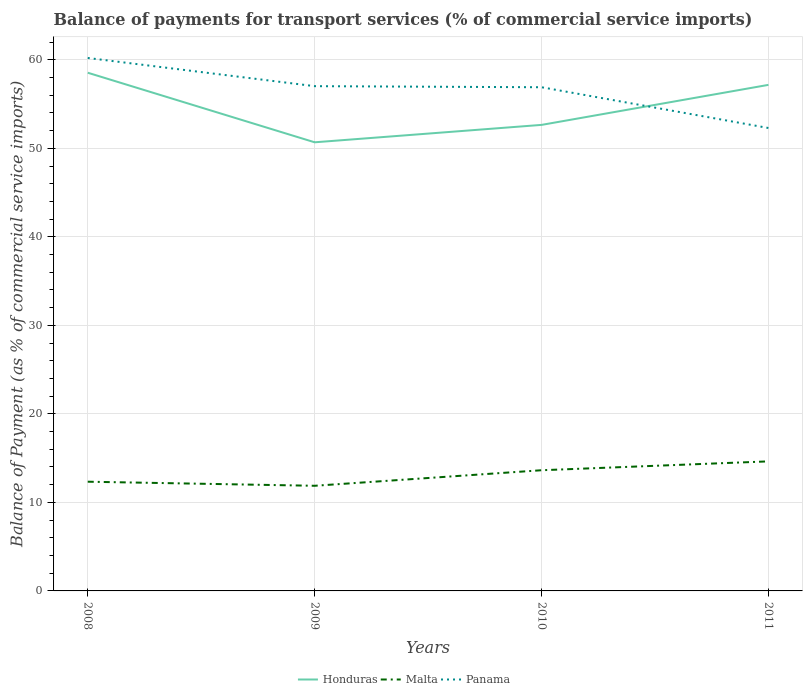How many different coloured lines are there?
Make the answer very short. 3. Across all years, what is the maximum balance of payments for transport services in Panama?
Offer a very short reply. 52.3. What is the total balance of payments for transport services in Honduras in the graph?
Offer a terse response. -4.52. What is the difference between the highest and the second highest balance of payments for transport services in Panama?
Your answer should be very brief. 7.91. What is the difference between the highest and the lowest balance of payments for transport services in Malta?
Provide a short and direct response. 2. What is the difference between two consecutive major ticks on the Y-axis?
Make the answer very short. 10. Does the graph contain grids?
Your answer should be very brief. Yes. What is the title of the graph?
Make the answer very short. Balance of payments for transport services (% of commercial service imports). Does "World" appear as one of the legend labels in the graph?
Provide a succinct answer. No. What is the label or title of the Y-axis?
Your answer should be compact. Balance of Payment (as % of commercial service imports). What is the Balance of Payment (as % of commercial service imports) in Honduras in 2008?
Make the answer very short. 58.54. What is the Balance of Payment (as % of commercial service imports) in Malta in 2008?
Keep it short and to the point. 12.34. What is the Balance of Payment (as % of commercial service imports) in Panama in 2008?
Keep it short and to the point. 60.21. What is the Balance of Payment (as % of commercial service imports) of Honduras in 2009?
Give a very brief answer. 50.68. What is the Balance of Payment (as % of commercial service imports) of Malta in 2009?
Your answer should be very brief. 11.88. What is the Balance of Payment (as % of commercial service imports) in Panama in 2009?
Offer a very short reply. 57.02. What is the Balance of Payment (as % of commercial service imports) in Honduras in 2010?
Provide a succinct answer. 52.65. What is the Balance of Payment (as % of commercial service imports) in Malta in 2010?
Offer a very short reply. 13.63. What is the Balance of Payment (as % of commercial service imports) of Panama in 2010?
Make the answer very short. 56.9. What is the Balance of Payment (as % of commercial service imports) of Honduras in 2011?
Your response must be concise. 57.17. What is the Balance of Payment (as % of commercial service imports) in Malta in 2011?
Your response must be concise. 14.64. What is the Balance of Payment (as % of commercial service imports) in Panama in 2011?
Give a very brief answer. 52.3. Across all years, what is the maximum Balance of Payment (as % of commercial service imports) in Honduras?
Provide a succinct answer. 58.54. Across all years, what is the maximum Balance of Payment (as % of commercial service imports) in Malta?
Offer a very short reply. 14.64. Across all years, what is the maximum Balance of Payment (as % of commercial service imports) in Panama?
Your answer should be very brief. 60.21. Across all years, what is the minimum Balance of Payment (as % of commercial service imports) in Honduras?
Provide a succinct answer. 50.68. Across all years, what is the minimum Balance of Payment (as % of commercial service imports) of Malta?
Your answer should be very brief. 11.88. Across all years, what is the minimum Balance of Payment (as % of commercial service imports) in Panama?
Provide a succinct answer. 52.3. What is the total Balance of Payment (as % of commercial service imports) of Honduras in the graph?
Your answer should be very brief. 219.04. What is the total Balance of Payment (as % of commercial service imports) of Malta in the graph?
Your response must be concise. 52.49. What is the total Balance of Payment (as % of commercial service imports) of Panama in the graph?
Make the answer very short. 226.43. What is the difference between the Balance of Payment (as % of commercial service imports) of Honduras in 2008 and that in 2009?
Provide a short and direct response. 7.86. What is the difference between the Balance of Payment (as % of commercial service imports) in Malta in 2008 and that in 2009?
Make the answer very short. 0.46. What is the difference between the Balance of Payment (as % of commercial service imports) of Panama in 2008 and that in 2009?
Keep it short and to the point. 3.19. What is the difference between the Balance of Payment (as % of commercial service imports) in Honduras in 2008 and that in 2010?
Your answer should be very brief. 5.89. What is the difference between the Balance of Payment (as % of commercial service imports) of Malta in 2008 and that in 2010?
Ensure brevity in your answer.  -1.3. What is the difference between the Balance of Payment (as % of commercial service imports) in Panama in 2008 and that in 2010?
Keep it short and to the point. 3.31. What is the difference between the Balance of Payment (as % of commercial service imports) in Honduras in 2008 and that in 2011?
Provide a succinct answer. 1.37. What is the difference between the Balance of Payment (as % of commercial service imports) of Malta in 2008 and that in 2011?
Ensure brevity in your answer.  -2.3. What is the difference between the Balance of Payment (as % of commercial service imports) in Panama in 2008 and that in 2011?
Keep it short and to the point. 7.91. What is the difference between the Balance of Payment (as % of commercial service imports) in Honduras in 2009 and that in 2010?
Ensure brevity in your answer.  -1.97. What is the difference between the Balance of Payment (as % of commercial service imports) in Malta in 2009 and that in 2010?
Your response must be concise. -1.76. What is the difference between the Balance of Payment (as % of commercial service imports) in Panama in 2009 and that in 2010?
Offer a terse response. 0.12. What is the difference between the Balance of Payment (as % of commercial service imports) of Honduras in 2009 and that in 2011?
Ensure brevity in your answer.  -6.49. What is the difference between the Balance of Payment (as % of commercial service imports) of Malta in 2009 and that in 2011?
Your answer should be compact. -2.76. What is the difference between the Balance of Payment (as % of commercial service imports) of Panama in 2009 and that in 2011?
Make the answer very short. 4.73. What is the difference between the Balance of Payment (as % of commercial service imports) in Honduras in 2010 and that in 2011?
Ensure brevity in your answer.  -4.52. What is the difference between the Balance of Payment (as % of commercial service imports) in Malta in 2010 and that in 2011?
Provide a succinct answer. -1. What is the difference between the Balance of Payment (as % of commercial service imports) in Panama in 2010 and that in 2011?
Keep it short and to the point. 4.61. What is the difference between the Balance of Payment (as % of commercial service imports) of Honduras in 2008 and the Balance of Payment (as % of commercial service imports) of Malta in 2009?
Keep it short and to the point. 46.66. What is the difference between the Balance of Payment (as % of commercial service imports) of Honduras in 2008 and the Balance of Payment (as % of commercial service imports) of Panama in 2009?
Offer a terse response. 1.52. What is the difference between the Balance of Payment (as % of commercial service imports) in Malta in 2008 and the Balance of Payment (as % of commercial service imports) in Panama in 2009?
Provide a short and direct response. -44.68. What is the difference between the Balance of Payment (as % of commercial service imports) of Honduras in 2008 and the Balance of Payment (as % of commercial service imports) of Malta in 2010?
Make the answer very short. 44.91. What is the difference between the Balance of Payment (as % of commercial service imports) in Honduras in 2008 and the Balance of Payment (as % of commercial service imports) in Panama in 2010?
Offer a terse response. 1.64. What is the difference between the Balance of Payment (as % of commercial service imports) of Malta in 2008 and the Balance of Payment (as % of commercial service imports) of Panama in 2010?
Ensure brevity in your answer.  -44.56. What is the difference between the Balance of Payment (as % of commercial service imports) of Honduras in 2008 and the Balance of Payment (as % of commercial service imports) of Malta in 2011?
Your response must be concise. 43.91. What is the difference between the Balance of Payment (as % of commercial service imports) in Honduras in 2008 and the Balance of Payment (as % of commercial service imports) in Panama in 2011?
Keep it short and to the point. 6.25. What is the difference between the Balance of Payment (as % of commercial service imports) of Malta in 2008 and the Balance of Payment (as % of commercial service imports) of Panama in 2011?
Offer a terse response. -39.96. What is the difference between the Balance of Payment (as % of commercial service imports) in Honduras in 2009 and the Balance of Payment (as % of commercial service imports) in Malta in 2010?
Your answer should be very brief. 37.05. What is the difference between the Balance of Payment (as % of commercial service imports) in Honduras in 2009 and the Balance of Payment (as % of commercial service imports) in Panama in 2010?
Make the answer very short. -6.22. What is the difference between the Balance of Payment (as % of commercial service imports) in Malta in 2009 and the Balance of Payment (as % of commercial service imports) in Panama in 2010?
Offer a terse response. -45.02. What is the difference between the Balance of Payment (as % of commercial service imports) in Honduras in 2009 and the Balance of Payment (as % of commercial service imports) in Malta in 2011?
Ensure brevity in your answer.  36.05. What is the difference between the Balance of Payment (as % of commercial service imports) in Honduras in 2009 and the Balance of Payment (as % of commercial service imports) in Panama in 2011?
Make the answer very short. -1.61. What is the difference between the Balance of Payment (as % of commercial service imports) of Malta in 2009 and the Balance of Payment (as % of commercial service imports) of Panama in 2011?
Your response must be concise. -40.42. What is the difference between the Balance of Payment (as % of commercial service imports) in Honduras in 2010 and the Balance of Payment (as % of commercial service imports) in Malta in 2011?
Provide a succinct answer. 38.01. What is the difference between the Balance of Payment (as % of commercial service imports) of Honduras in 2010 and the Balance of Payment (as % of commercial service imports) of Panama in 2011?
Ensure brevity in your answer.  0.35. What is the difference between the Balance of Payment (as % of commercial service imports) in Malta in 2010 and the Balance of Payment (as % of commercial service imports) in Panama in 2011?
Your response must be concise. -38.66. What is the average Balance of Payment (as % of commercial service imports) in Honduras per year?
Offer a very short reply. 54.76. What is the average Balance of Payment (as % of commercial service imports) in Malta per year?
Give a very brief answer. 13.12. What is the average Balance of Payment (as % of commercial service imports) in Panama per year?
Keep it short and to the point. 56.61. In the year 2008, what is the difference between the Balance of Payment (as % of commercial service imports) of Honduras and Balance of Payment (as % of commercial service imports) of Malta?
Provide a succinct answer. 46.2. In the year 2008, what is the difference between the Balance of Payment (as % of commercial service imports) in Honduras and Balance of Payment (as % of commercial service imports) in Panama?
Your answer should be compact. -1.67. In the year 2008, what is the difference between the Balance of Payment (as % of commercial service imports) of Malta and Balance of Payment (as % of commercial service imports) of Panama?
Offer a very short reply. -47.87. In the year 2009, what is the difference between the Balance of Payment (as % of commercial service imports) in Honduras and Balance of Payment (as % of commercial service imports) in Malta?
Provide a succinct answer. 38.8. In the year 2009, what is the difference between the Balance of Payment (as % of commercial service imports) of Honduras and Balance of Payment (as % of commercial service imports) of Panama?
Keep it short and to the point. -6.34. In the year 2009, what is the difference between the Balance of Payment (as % of commercial service imports) of Malta and Balance of Payment (as % of commercial service imports) of Panama?
Your answer should be very brief. -45.14. In the year 2010, what is the difference between the Balance of Payment (as % of commercial service imports) of Honduras and Balance of Payment (as % of commercial service imports) of Malta?
Offer a terse response. 39.01. In the year 2010, what is the difference between the Balance of Payment (as % of commercial service imports) in Honduras and Balance of Payment (as % of commercial service imports) in Panama?
Give a very brief answer. -4.25. In the year 2010, what is the difference between the Balance of Payment (as % of commercial service imports) of Malta and Balance of Payment (as % of commercial service imports) of Panama?
Provide a short and direct response. -43.27. In the year 2011, what is the difference between the Balance of Payment (as % of commercial service imports) of Honduras and Balance of Payment (as % of commercial service imports) of Malta?
Ensure brevity in your answer.  42.53. In the year 2011, what is the difference between the Balance of Payment (as % of commercial service imports) of Honduras and Balance of Payment (as % of commercial service imports) of Panama?
Your response must be concise. 4.87. In the year 2011, what is the difference between the Balance of Payment (as % of commercial service imports) in Malta and Balance of Payment (as % of commercial service imports) in Panama?
Offer a very short reply. -37.66. What is the ratio of the Balance of Payment (as % of commercial service imports) of Honduras in 2008 to that in 2009?
Offer a very short reply. 1.16. What is the ratio of the Balance of Payment (as % of commercial service imports) in Malta in 2008 to that in 2009?
Ensure brevity in your answer.  1.04. What is the ratio of the Balance of Payment (as % of commercial service imports) in Panama in 2008 to that in 2009?
Offer a very short reply. 1.06. What is the ratio of the Balance of Payment (as % of commercial service imports) in Honduras in 2008 to that in 2010?
Keep it short and to the point. 1.11. What is the ratio of the Balance of Payment (as % of commercial service imports) of Malta in 2008 to that in 2010?
Make the answer very short. 0.9. What is the ratio of the Balance of Payment (as % of commercial service imports) in Panama in 2008 to that in 2010?
Your response must be concise. 1.06. What is the ratio of the Balance of Payment (as % of commercial service imports) of Honduras in 2008 to that in 2011?
Your answer should be compact. 1.02. What is the ratio of the Balance of Payment (as % of commercial service imports) of Malta in 2008 to that in 2011?
Your response must be concise. 0.84. What is the ratio of the Balance of Payment (as % of commercial service imports) of Panama in 2008 to that in 2011?
Keep it short and to the point. 1.15. What is the ratio of the Balance of Payment (as % of commercial service imports) of Honduras in 2009 to that in 2010?
Your answer should be compact. 0.96. What is the ratio of the Balance of Payment (as % of commercial service imports) of Malta in 2009 to that in 2010?
Your answer should be very brief. 0.87. What is the ratio of the Balance of Payment (as % of commercial service imports) of Panama in 2009 to that in 2010?
Provide a succinct answer. 1. What is the ratio of the Balance of Payment (as % of commercial service imports) of Honduras in 2009 to that in 2011?
Your response must be concise. 0.89. What is the ratio of the Balance of Payment (as % of commercial service imports) of Malta in 2009 to that in 2011?
Offer a terse response. 0.81. What is the ratio of the Balance of Payment (as % of commercial service imports) in Panama in 2009 to that in 2011?
Your answer should be very brief. 1.09. What is the ratio of the Balance of Payment (as % of commercial service imports) in Honduras in 2010 to that in 2011?
Your answer should be very brief. 0.92. What is the ratio of the Balance of Payment (as % of commercial service imports) in Malta in 2010 to that in 2011?
Ensure brevity in your answer.  0.93. What is the ratio of the Balance of Payment (as % of commercial service imports) in Panama in 2010 to that in 2011?
Your answer should be compact. 1.09. What is the difference between the highest and the second highest Balance of Payment (as % of commercial service imports) in Honduras?
Give a very brief answer. 1.37. What is the difference between the highest and the second highest Balance of Payment (as % of commercial service imports) of Malta?
Offer a very short reply. 1. What is the difference between the highest and the second highest Balance of Payment (as % of commercial service imports) of Panama?
Ensure brevity in your answer.  3.19. What is the difference between the highest and the lowest Balance of Payment (as % of commercial service imports) in Honduras?
Keep it short and to the point. 7.86. What is the difference between the highest and the lowest Balance of Payment (as % of commercial service imports) in Malta?
Provide a short and direct response. 2.76. What is the difference between the highest and the lowest Balance of Payment (as % of commercial service imports) of Panama?
Your answer should be very brief. 7.91. 